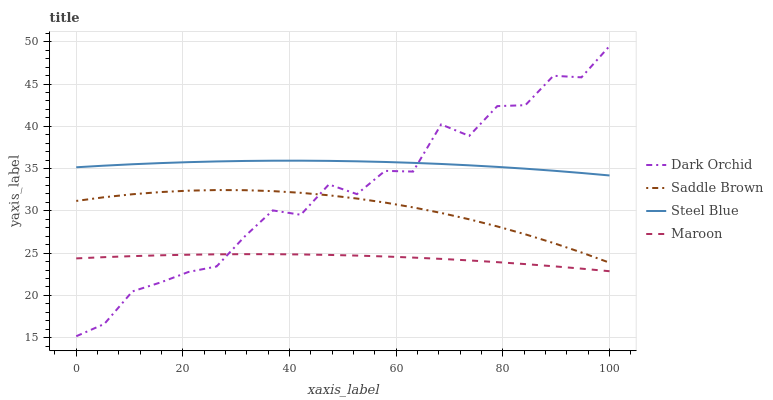Does Maroon have the minimum area under the curve?
Answer yes or no. Yes. Does Steel Blue have the maximum area under the curve?
Answer yes or no. Yes. Does Saddle Brown have the minimum area under the curve?
Answer yes or no. No. Does Saddle Brown have the maximum area under the curve?
Answer yes or no. No. Is Maroon the smoothest?
Answer yes or no. Yes. Is Dark Orchid the roughest?
Answer yes or no. Yes. Is Saddle Brown the smoothest?
Answer yes or no. No. Is Saddle Brown the roughest?
Answer yes or no. No. Does Dark Orchid have the lowest value?
Answer yes or no. Yes. Does Saddle Brown have the lowest value?
Answer yes or no. No. Does Dark Orchid have the highest value?
Answer yes or no. Yes. Does Saddle Brown have the highest value?
Answer yes or no. No. Is Maroon less than Steel Blue?
Answer yes or no. Yes. Is Steel Blue greater than Maroon?
Answer yes or no. Yes. Does Maroon intersect Dark Orchid?
Answer yes or no. Yes. Is Maroon less than Dark Orchid?
Answer yes or no. No. Is Maroon greater than Dark Orchid?
Answer yes or no. No. Does Maroon intersect Steel Blue?
Answer yes or no. No. 